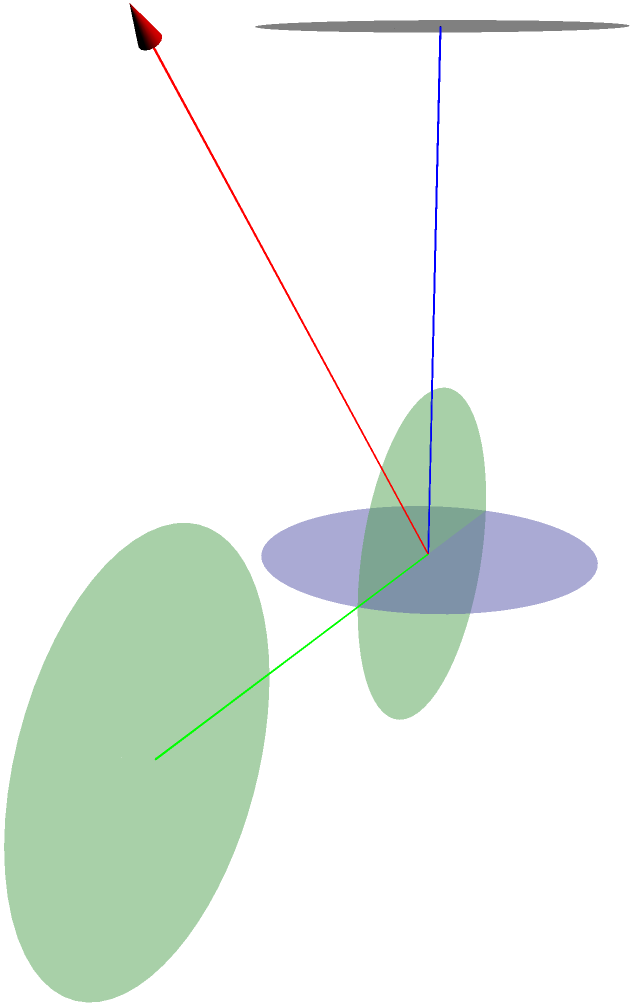In your latest track, you're spittin' bars about the intersection of two perpendicular cylinders, each with radius $r$ and height $h$. The curve formed by their intersection is known as Viviani's curve. What's the volume $V$ of the region common to both cylinders? Drop it like it's hot in terms of $r$ and $h$. Let's break this down step by step, like crafting the perfect verse:

1) First, visualize the setup. We have two cylinders intersecting at right angles, forming Viviani's curve.

2) The key to solving this is to realize that for any point $(x,y,z)$ on the intersection curve:
   $x^2 + y^2 = r^2$ (from the cylinder along the z-axis)
   $x^2 + z^2 = r^2$ (from the cylinder along the y-axis)

3) Subtracting these equations: $y^2 - z^2 = 0$, or $y = \pm z$

4) The intersection curve can be parameterized as:
   $x = r\cos(t)$, $y = r\sin(t)$, $z = r\sin(t)$, where $0 \leq t \leq 2\pi$

5) To find the volume, we can integrate the area of the intersection along the height:

   $$V = \int_0^h A(z) dz$$

   where $A(z)$ is the area of the intersection at height $z$.

6) At any height $z$, the intersection forms a square with side length $2\sqrt{r^2-z^2}$

7) Therefore, $A(z) = 4(r^2-z^2)$

8) Now we can set up our integral:

   $$V = \int_0^h 4(r^2-z^2) dz$$

9) Evaluating this integral:

   $$V = 4[r^2z - \frac{1}{3}z^3]_0^h = 4(r^2h - \frac{1}{3}h^3)$$

10) Simplifying:

    $$V = \frac{16}{3}r^2h - \frac{4}{3}h^3$$

And that's the volume, dropped like it's hot!
Answer: $\frac{16}{3}r^2h - \frac{4}{3}h^3$ 